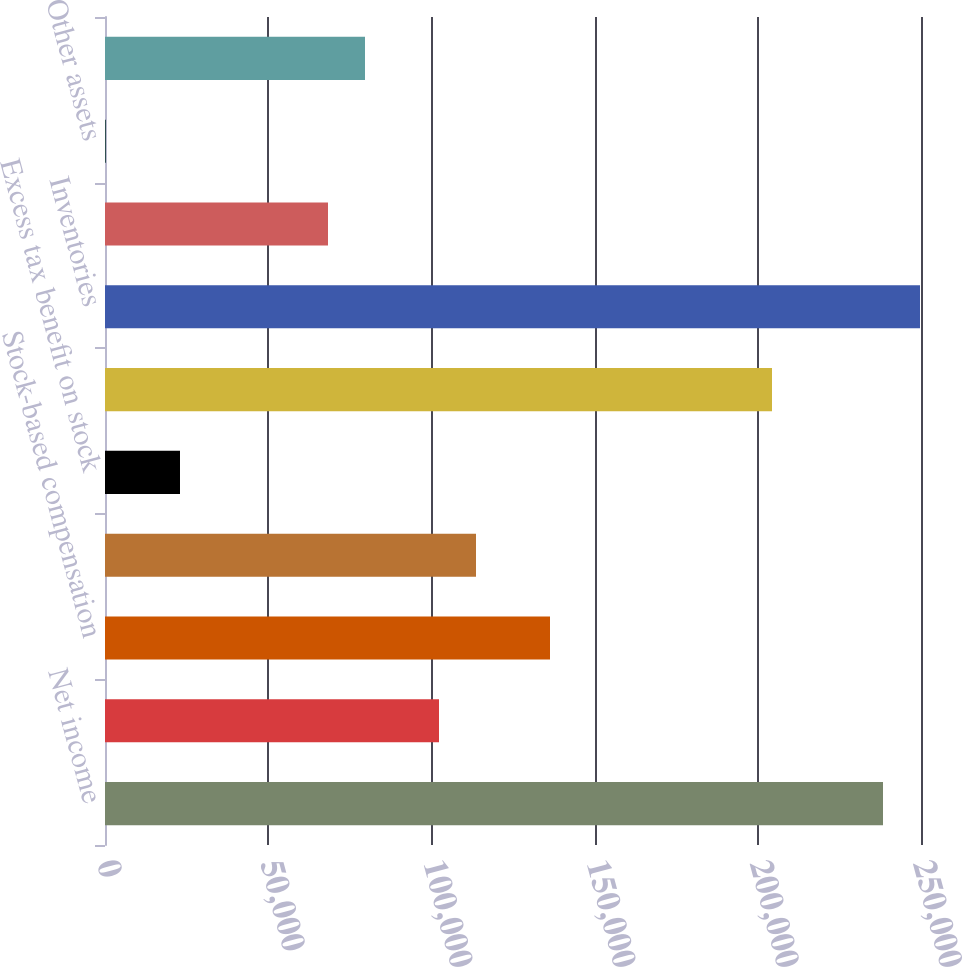Convert chart to OTSL. <chart><loc_0><loc_0><loc_500><loc_500><bar_chart><fcel>Net income<fcel>Depreciation and amortization<fcel>Stock-based compensation<fcel>Deferred income taxes<fcel>Excess tax benefit on stock<fcel>Accounts receivable net<fcel>Inventories<fcel>Prepaid expenses and other<fcel>Other assets<fcel>Accounts payable<nl><fcel>238359<fcel>102328<fcel>136336<fcel>113664<fcel>22976.8<fcel>204351<fcel>249695<fcel>68320.4<fcel>305<fcel>79656.3<nl></chart> 